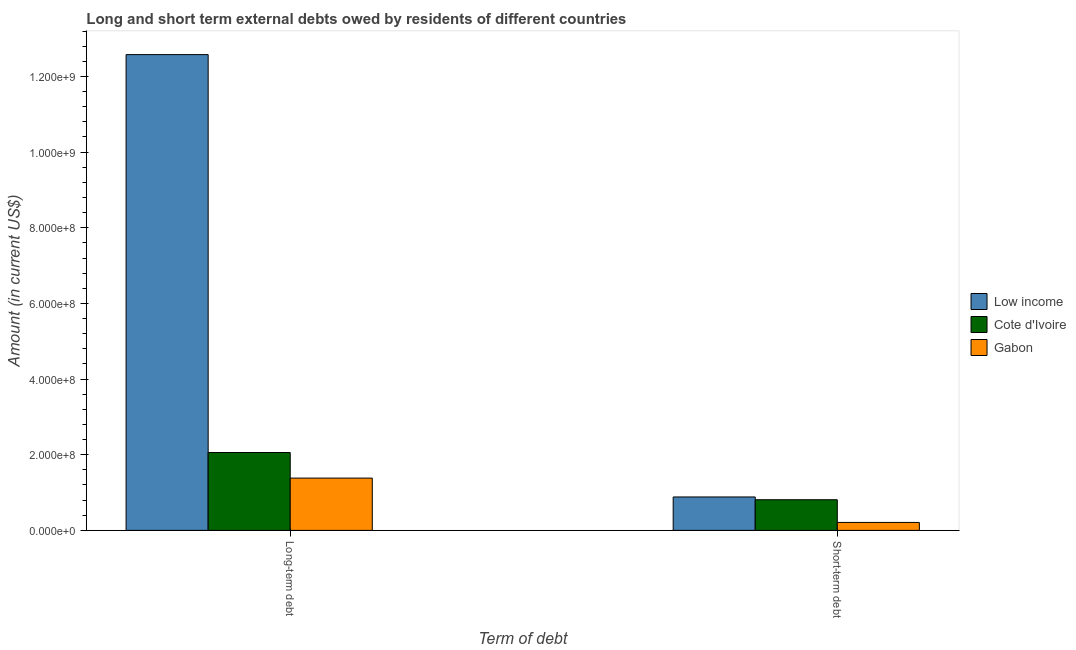How many bars are there on the 2nd tick from the left?
Offer a terse response. 3. How many bars are there on the 1st tick from the right?
Provide a short and direct response. 3. What is the label of the 1st group of bars from the left?
Your response must be concise. Long-term debt. What is the long-term debts owed by residents in Low income?
Your answer should be very brief. 1.26e+09. Across all countries, what is the maximum long-term debts owed by residents?
Offer a very short reply. 1.26e+09. Across all countries, what is the minimum long-term debts owed by residents?
Your answer should be very brief. 1.38e+08. In which country was the long-term debts owed by residents minimum?
Your answer should be compact. Gabon. What is the total short-term debts owed by residents in the graph?
Keep it short and to the point. 1.90e+08. What is the difference between the long-term debts owed by residents in Gabon and that in Low income?
Your response must be concise. -1.12e+09. What is the difference between the long-term debts owed by residents in Gabon and the short-term debts owed by residents in Cote d'Ivoire?
Provide a succinct answer. 5.72e+07. What is the average long-term debts owed by residents per country?
Provide a short and direct response. 5.34e+08. What is the difference between the short-term debts owed by residents and long-term debts owed by residents in Gabon?
Offer a terse response. -1.17e+08. What is the ratio of the long-term debts owed by residents in Cote d'Ivoire to that in Gabon?
Keep it short and to the point. 1.49. Is the long-term debts owed by residents in Low income less than that in Gabon?
Ensure brevity in your answer.  No. What does the 3rd bar from the right in Long-term debt represents?
Provide a short and direct response. Low income. Are all the bars in the graph horizontal?
Keep it short and to the point. No. How many countries are there in the graph?
Offer a terse response. 3. Are the values on the major ticks of Y-axis written in scientific E-notation?
Offer a terse response. Yes. Does the graph contain any zero values?
Your answer should be compact. No. Where does the legend appear in the graph?
Keep it short and to the point. Center right. What is the title of the graph?
Your answer should be compact. Long and short term external debts owed by residents of different countries. Does "Tonga" appear as one of the legend labels in the graph?
Ensure brevity in your answer.  No. What is the label or title of the X-axis?
Offer a terse response. Term of debt. What is the label or title of the Y-axis?
Give a very brief answer. Amount (in current US$). What is the Amount (in current US$) of Low income in Long-term debt?
Your answer should be very brief. 1.26e+09. What is the Amount (in current US$) of Cote d'Ivoire in Long-term debt?
Keep it short and to the point. 2.06e+08. What is the Amount (in current US$) in Gabon in Long-term debt?
Offer a very short reply. 1.38e+08. What is the Amount (in current US$) of Low income in Short-term debt?
Offer a terse response. 8.84e+07. What is the Amount (in current US$) in Cote d'Ivoire in Short-term debt?
Your response must be concise. 8.10e+07. What is the Amount (in current US$) of Gabon in Short-term debt?
Give a very brief answer. 2.10e+07. Across all Term of debt, what is the maximum Amount (in current US$) of Low income?
Keep it short and to the point. 1.26e+09. Across all Term of debt, what is the maximum Amount (in current US$) of Cote d'Ivoire?
Ensure brevity in your answer.  2.06e+08. Across all Term of debt, what is the maximum Amount (in current US$) in Gabon?
Provide a short and direct response. 1.38e+08. Across all Term of debt, what is the minimum Amount (in current US$) of Low income?
Your response must be concise. 8.84e+07. Across all Term of debt, what is the minimum Amount (in current US$) in Cote d'Ivoire?
Make the answer very short. 8.10e+07. Across all Term of debt, what is the minimum Amount (in current US$) of Gabon?
Offer a very short reply. 2.10e+07. What is the total Amount (in current US$) of Low income in the graph?
Provide a succinct answer. 1.35e+09. What is the total Amount (in current US$) in Cote d'Ivoire in the graph?
Make the answer very short. 2.87e+08. What is the total Amount (in current US$) in Gabon in the graph?
Give a very brief answer. 1.59e+08. What is the difference between the Amount (in current US$) of Low income in Long-term debt and that in Short-term debt?
Your response must be concise. 1.17e+09. What is the difference between the Amount (in current US$) in Cote d'Ivoire in Long-term debt and that in Short-term debt?
Your answer should be very brief. 1.25e+08. What is the difference between the Amount (in current US$) in Gabon in Long-term debt and that in Short-term debt?
Your answer should be compact. 1.17e+08. What is the difference between the Amount (in current US$) of Low income in Long-term debt and the Amount (in current US$) of Cote d'Ivoire in Short-term debt?
Provide a short and direct response. 1.18e+09. What is the difference between the Amount (in current US$) of Low income in Long-term debt and the Amount (in current US$) of Gabon in Short-term debt?
Provide a succinct answer. 1.24e+09. What is the difference between the Amount (in current US$) of Cote d'Ivoire in Long-term debt and the Amount (in current US$) of Gabon in Short-term debt?
Ensure brevity in your answer.  1.85e+08. What is the average Amount (in current US$) of Low income per Term of debt?
Provide a short and direct response. 6.73e+08. What is the average Amount (in current US$) of Cote d'Ivoire per Term of debt?
Give a very brief answer. 1.43e+08. What is the average Amount (in current US$) in Gabon per Term of debt?
Give a very brief answer. 7.96e+07. What is the difference between the Amount (in current US$) in Low income and Amount (in current US$) in Cote d'Ivoire in Long-term debt?
Give a very brief answer. 1.05e+09. What is the difference between the Amount (in current US$) of Low income and Amount (in current US$) of Gabon in Long-term debt?
Keep it short and to the point. 1.12e+09. What is the difference between the Amount (in current US$) in Cote d'Ivoire and Amount (in current US$) in Gabon in Long-term debt?
Your answer should be compact. 6.77e+07. What is the difference between the Amount (in current US$) in Low income and Amount (in current US$) in Cote d'Ivoire in Short-term debt?
Provide a short and direct response. 7.35e+06. What is the difference between the Amount (in current US$) of Low income and Amount (in current US$) of Gabon in Short-term debt?
Provide a short and direct response. 6.74e+07. What is the difference between the Amount (in current US$) of Cote d'Ivoire and Amount (in current US$) of Gabon in Short-term debt?
Ensure brevity in your answer.  6.00e+07. What is the ratio of the Amount (in current US$) in Low income in Long-term debt to that in Short-term debt?
Keep it short and to the point. 14.23. What is the ratio of the Amount (in current US$) of Cote d'Ivoire in Long-term debt to that in Short-term debt?
Your answer should be compact. 2.54. What is the ratio of the Amount (in current US$) in Gabon in Long-term debt to that in Short-term debt?
Provide a succinct answer. 6.58. What is the difference between the highest and the second highest Amount (in current US$) of Low income?
Provide a succinct answer. 1.17e+09. What is the difference between the highest and the second highest Amount (in current US$) in Cote d'Ivoire?
Your answer should be compact. 1.25e+08. What is the difference between the highest and the second highest Amount (in current US$) in Gabon?
Your answer should be compact. 1.17e+08. What is the difference between the highest and the lowest Amount (in current US$) of Low income?
Ensure brevity in your answer.  1.17e+09. What is the difference between the highest and the lowest Amount (in current US$) of Cote d'Ivoire?
Offer a terse response. 1.25e+08. What is the difference between the highest and the lowest Amount (in current US$) in Gabon?
Your answer should be very brief. 1.17e+08. 